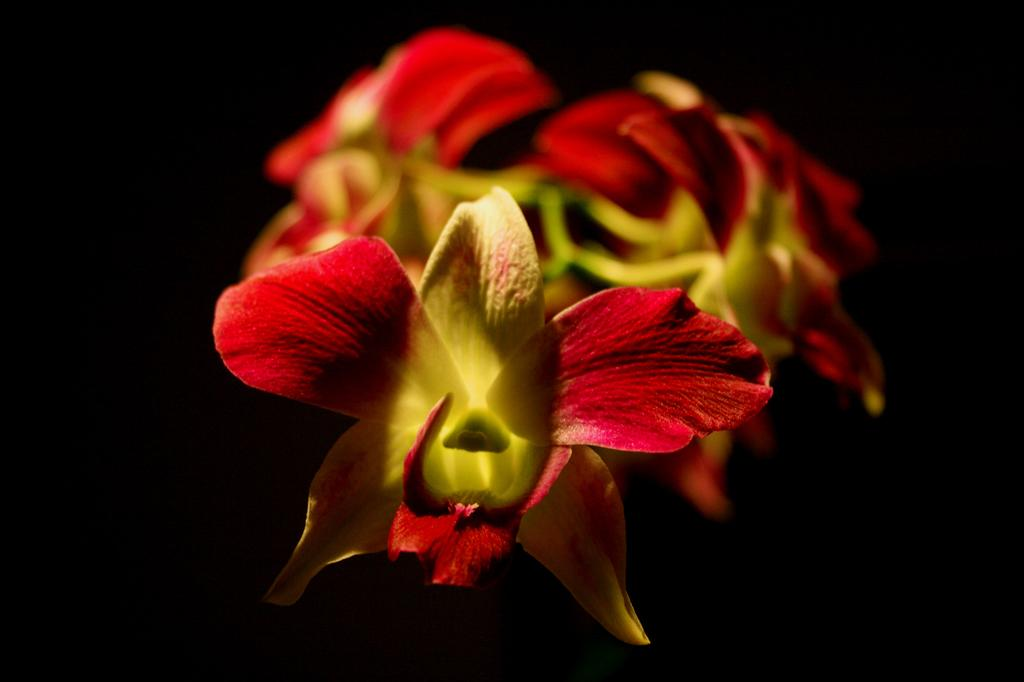What is the main subject of the image? There is a flower in the image. Can you describe the background of the image? There are flowers visible in the background of the image. What type of chain can be seen holding the flower in the image? There is no chain present in the image; the flower is not being held by any chain. 